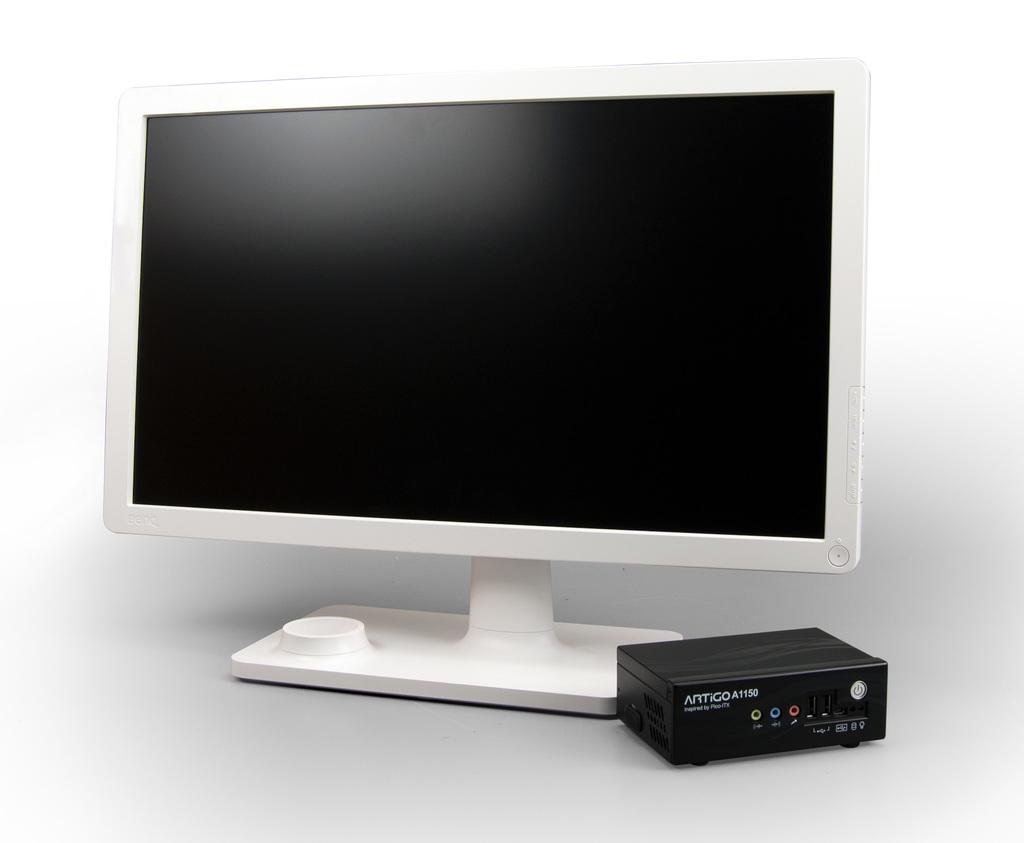What brand is the speaker box?
Provide a succinct answer. Artigo. 